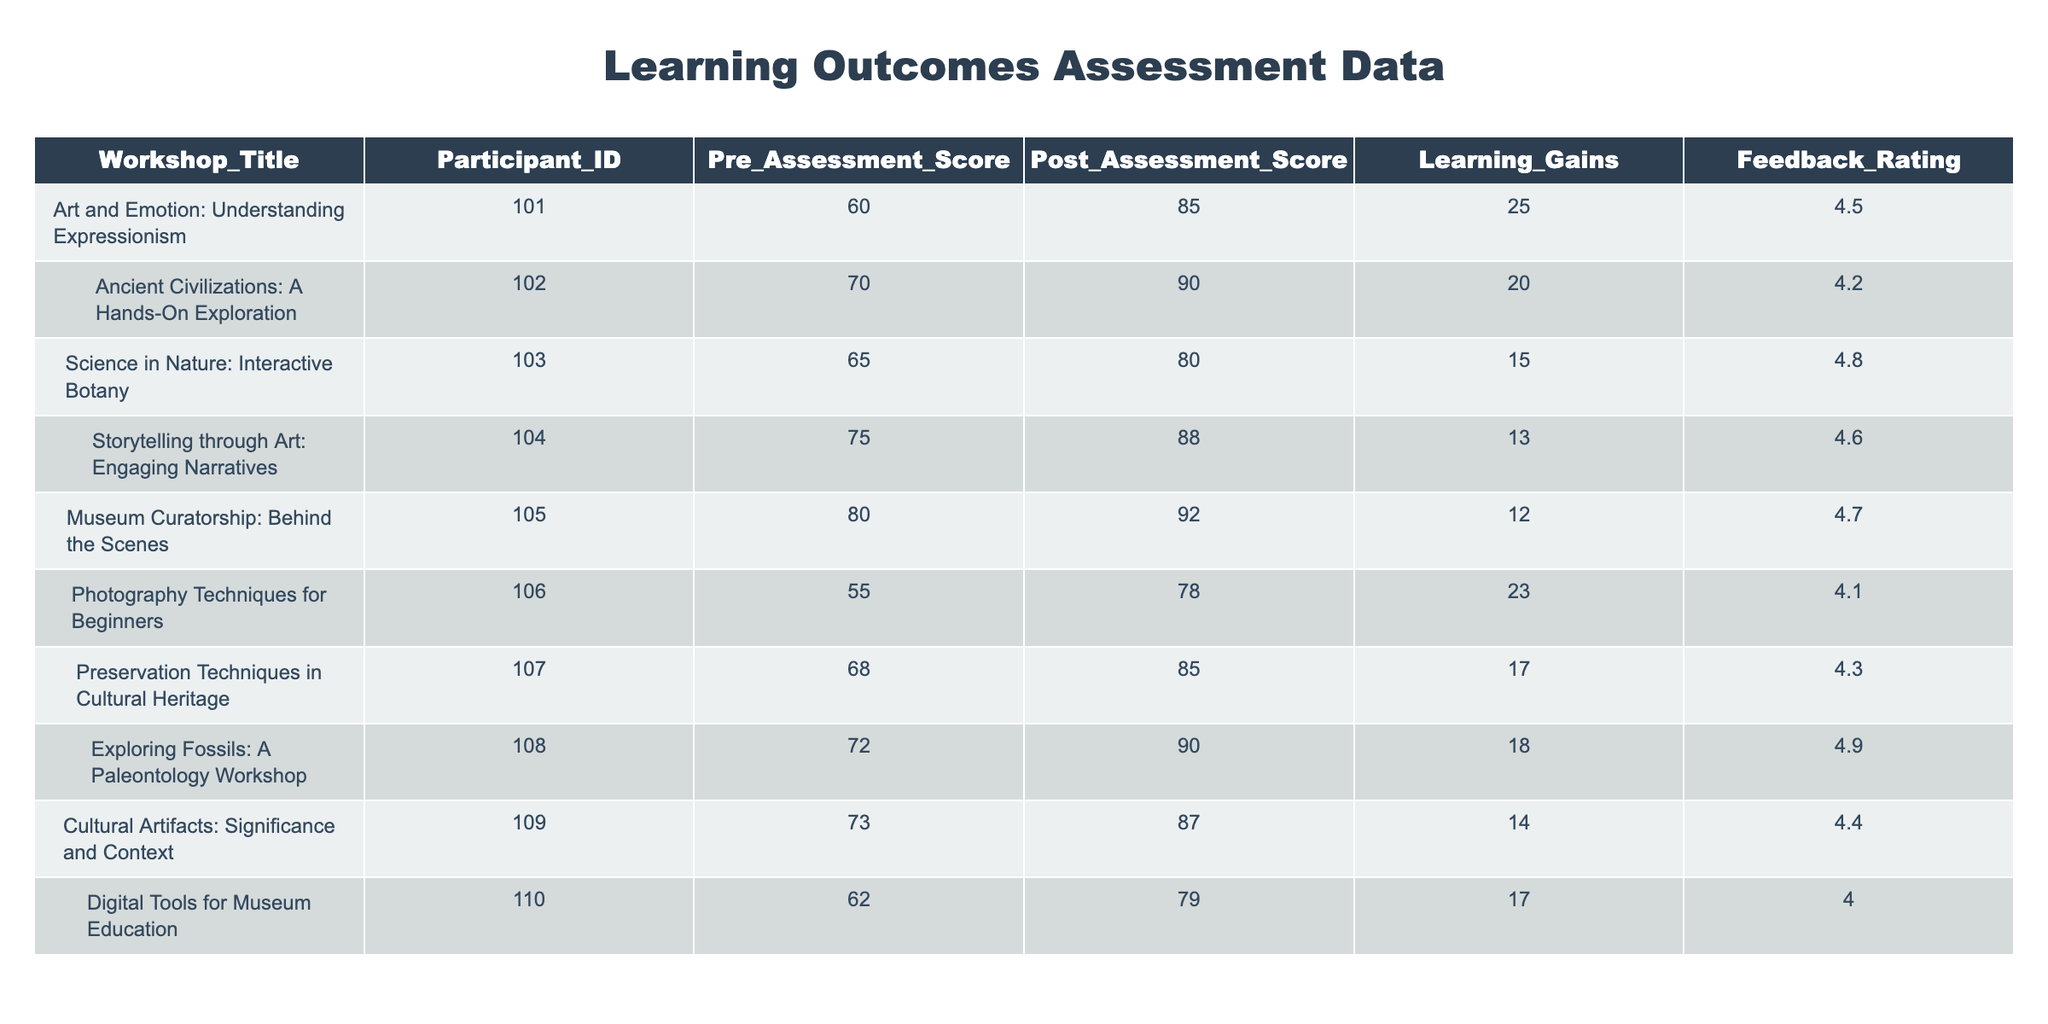What is the feedback rating for the workshop titled "Exploring Fossils: A Paleontology Workshop"? In the table, I can find the row corresponding to the workshop "Exploring Fossils: A Paleontology Workshop". The feedback rating in that row is listed as 4.9.
Answer: 4.9 What is the highest post-assessment score recorded in this table? I look through the Post_Assessment_Score column and see that the highest number is 92, which corresponds to the workshop "Museum Curatorship: Behind the Scenes".
Answer: 92 What is the average learning gain for all workshops listed? To find the average learning gain, I sum up all the Learning Gains: 25 + 20 + 15 + 13 + 12 + 23 + 17 + 18 + 14 + 17 =  180. There are 10 workshops, so I divide 180 by 10, which gives me 18.
Answer: 18 Did any workshop have a learning gain of more than 20? Looking at the Learning Gains column, the workshops "Art and Emotion: Understanding Expressionism" and "Photography Techniques for Beginners" have learning gains of 25 and 23 respectively. Therefore, there are workshops that exceed 20.
Answer: Yes What is the difference between the highest and lowest pre-assessment scores? The highest pre-assessment score is 80 (from "Museum Curatorship: Behind the Scenes") and the lowest is 55 (from "Photography Techniques for Beginners"). The difference is 80 - 55 = 25.
Answer: 25 How many workshops received a feedback rating of 4.5 or higher? I check the Feedback Rating column and see that the ratings of 4.5 or higher are: 4.5, 4.8, 4.6, 4.7, 4.9, and 4.4. This totals to six workshops.
Answer: 6 Which workshop had the smallest learning gain and what was that gain? I review the Learning Gains column and find that the workshop "Storytelling through Art: Engaging Narratives" has the smallest learning gain of 13.
Answer: 13 Is there a workshop with a feedback rating of exactly 4.0? I check the Feedback Rating column and find that "Digital Tools for Museum Education" has a rating of 4.0, confirming that there is a matching workshop.
Answer: Yes In terms of learning gains, which two workshops had the closest scores? I compare all the learning gains: "Gallery Techniques for Beginners" (23), "Art and Emotion: Understanding Expressionism" (25), and so on. The closest scores are "Digital Tools for Museum Education" (17) and "Preservation Techniques in Cultural Heritage" (17), both having a gain of 17.
Answer: Digital Tools for Museum Education and Preservation Techniques in Cultural Heritage 